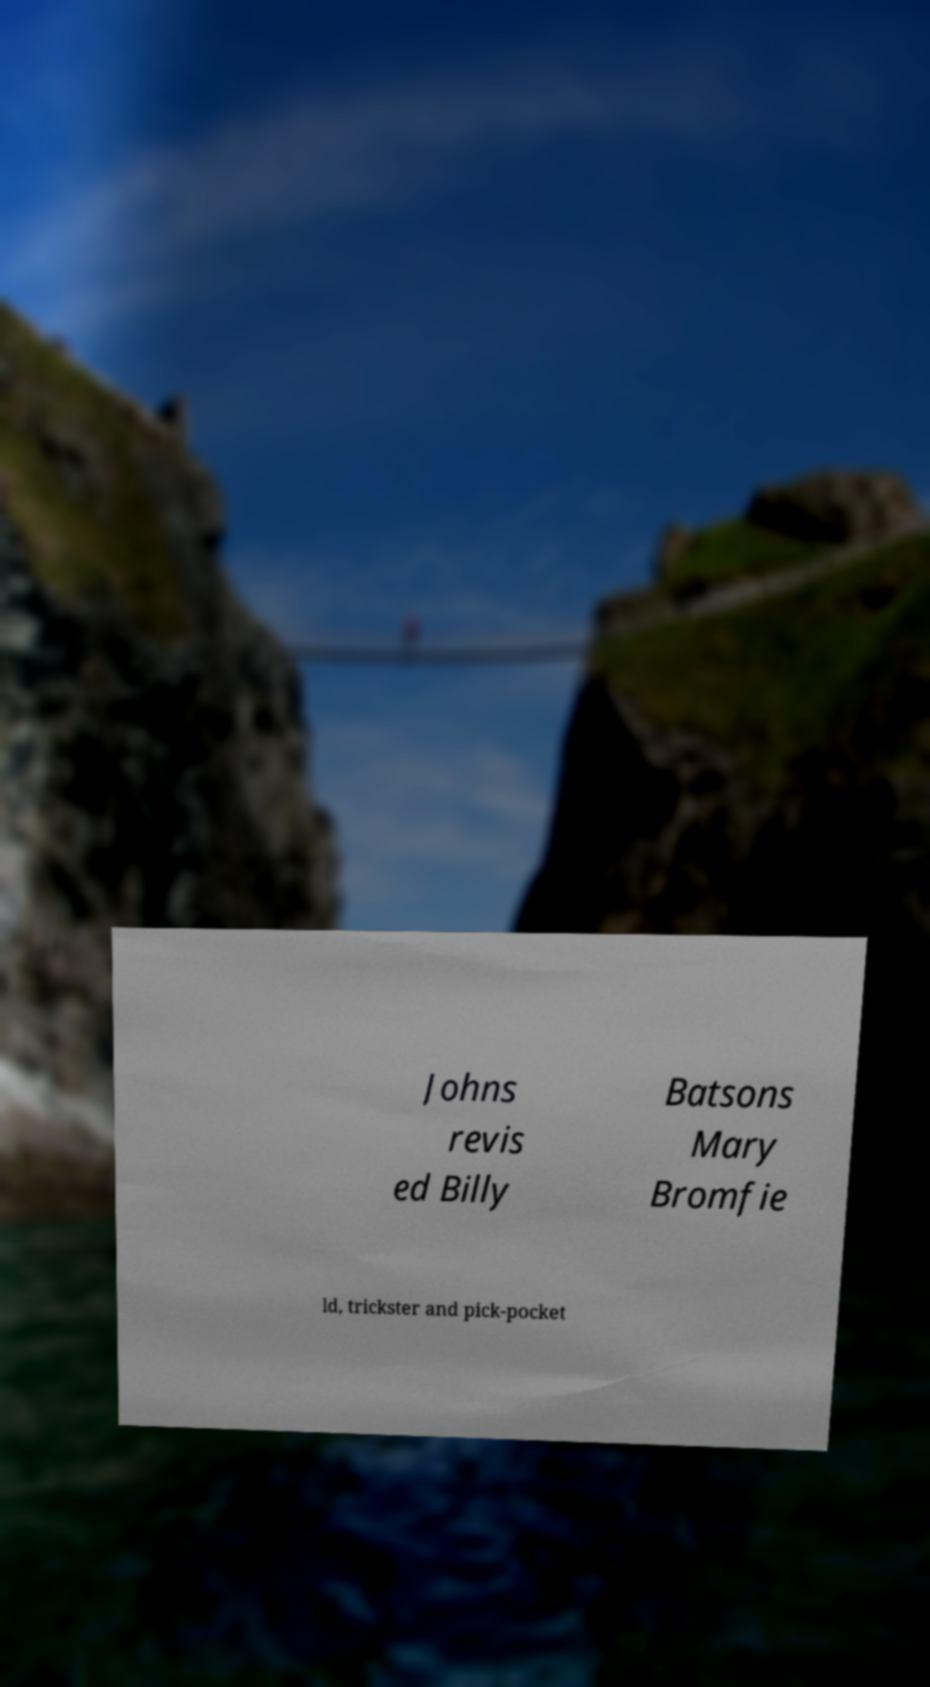Could you extract and type out the text from this image? Johns revis ed Billy Batsons Mary Bromfie ld, trickster and pick-pocket 